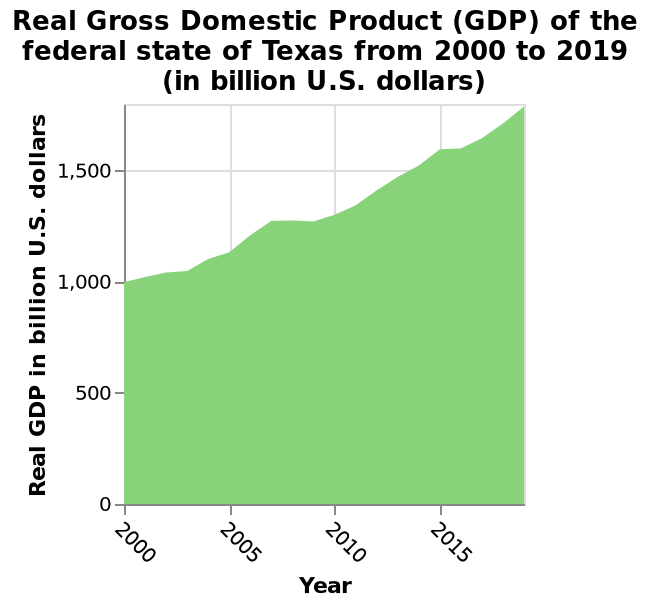<image>
Was there any point during the years 2000 to 2019 where the GDP of Texas stagnated? Yes, there were brief periods where the GDP of Texas stagnated between 2000 and 2019. 